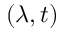<formula> <loc_0><loc_0><loc_500><loc_500>( \lambda , t )</formula> 